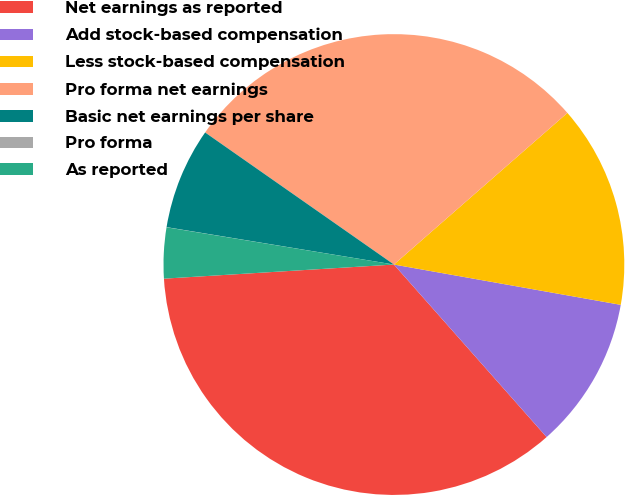<chart> <loc_0><loc_0><loc_500><loc_500><pie_chart><fcel>Net earnings as reported<fcel>Add stock-based compensation<fcel>Less stock-based compensation<fcel>Pro forma net earnings<fcel>Basic net earnings per share<fcel>Pro forma<fcel>As reported<nl><fcel>35.55%<fcel>10.67%<fcel>14.23%<fcel>28.85%<fcel>7.12%<fcel>0.01%<fcel>3.56%<nl></chart> 